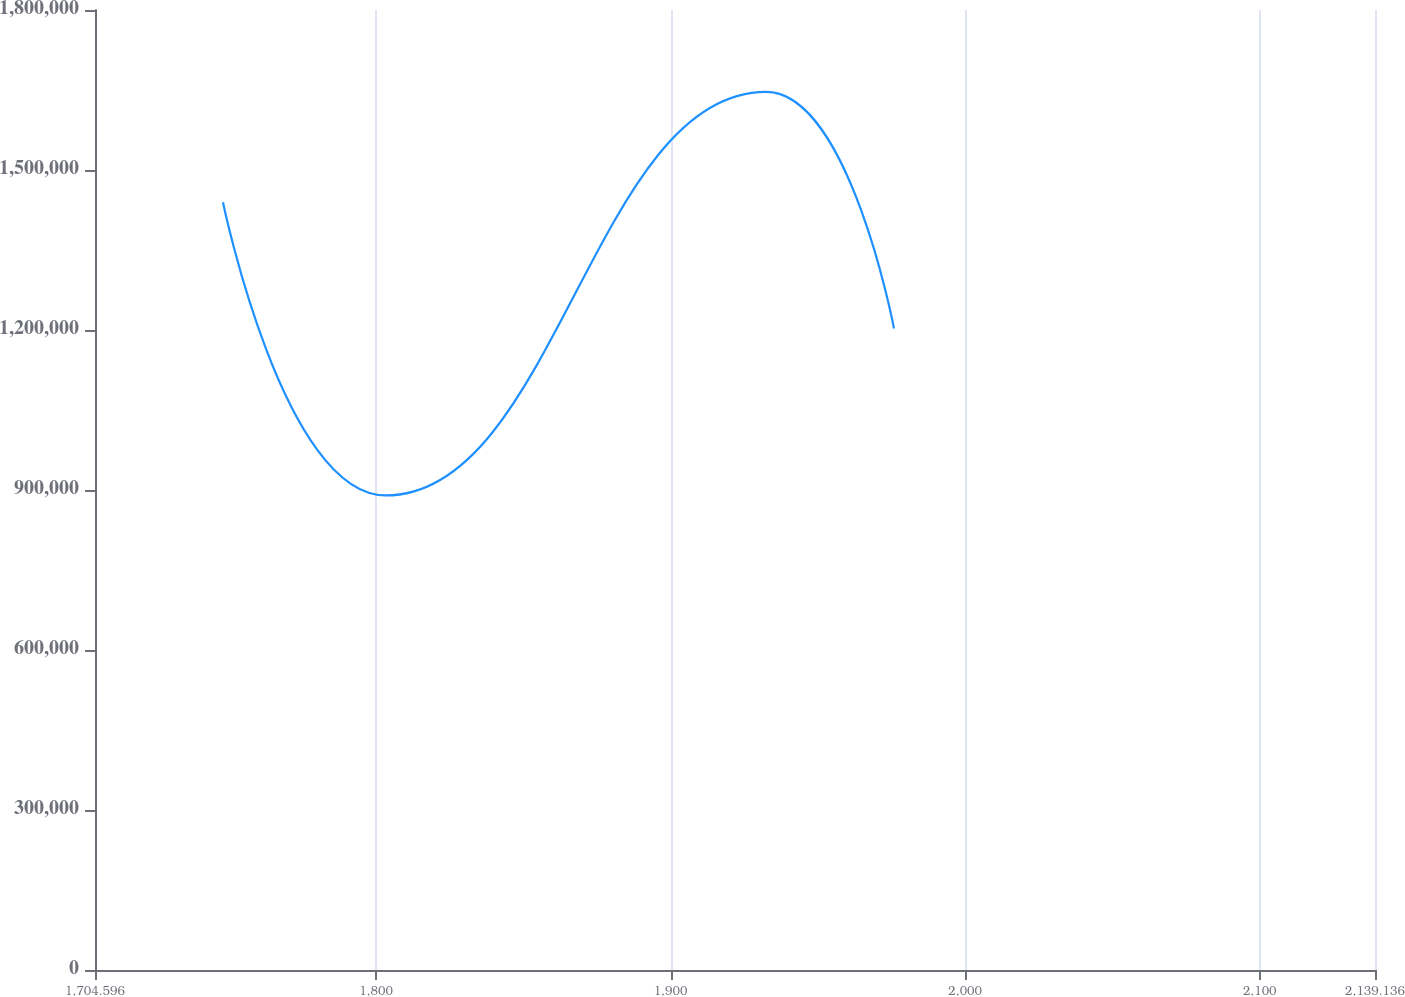Convert chart. <chart><loc_0><loc_0><loc_500><loc_500><line_chart><ecel><fcel>Unnamed: 1<nl><fcel>1748.05<fcel>1.43954e+06<nl><fcel>1803.29<fcel>889823<nl><fcel>1932.39<fcel>1.64638e+06<nl><fcel>1975.84<fcel>1.20284e+06<nl><fcel>2182.59<fcel>635292<nl></chart> 